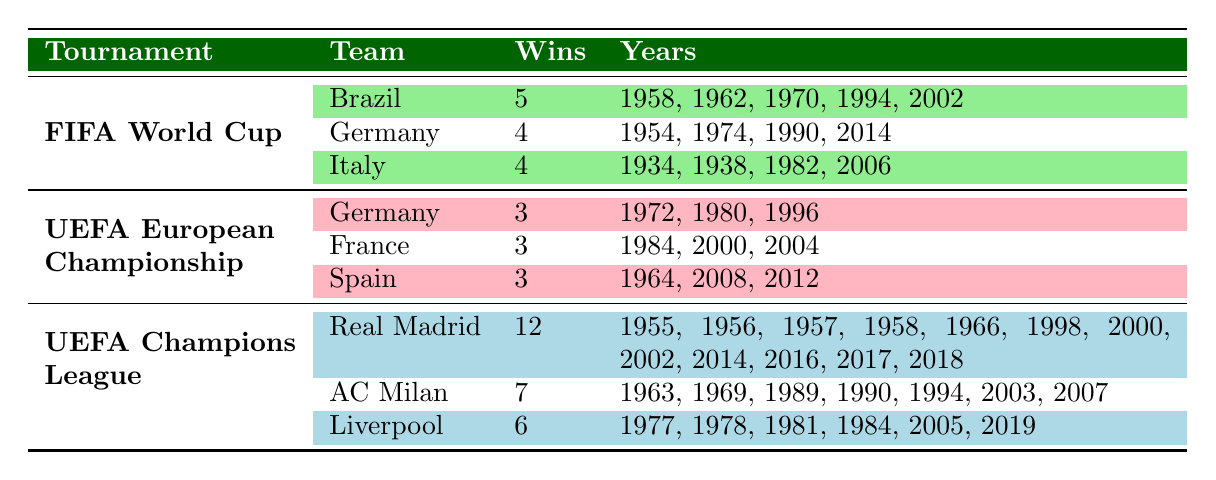What team has the most wins in the UEFA Champions League? Real Madrid has the most wins in the UEFA Champions League with a total of 12 victories, as indicated in the "Wins" column.
Answer: Real Madrid How many titles has Brazil won in the FIFA World Cup? Brazil has won the FIFA World Cup a total of 5 times, which is evident from the "Wins" column under the FIFA World Cup section.
Answer: 5 Did Italy win the UEFA European Championship more times than France? Italy and France have both won the UEFA European Championship 3 times, according to the table. Thus, it is false that Italy has more wins than France.
Answer: No Which team has the same number of UEFA European Championship wins as Spain? Germany and France both have 3 wins each in the UEFA European Championship, matching Spain's 3 wins. This is seen in the "Wins" column.
Answer: Germany, France How many total wins does Liverpool have across all tournaments listed? Liverpool has 6 wins in the UEFA Champions League. There are no wins recorded for Liverpool in the other tournaments. Therefore, the total number of wins for Liverpool is 6.
Answer: 6 Which team has won the FIFA World Cup more frequently, Germany or Italy? Germany has won the FIFA World Cup 4 times, while Italy has won it 4 times as well, meaning both teams have the same number of wins, as shown in the "Wins" column.
Answer: They are equal What is the average number of wins for teams in the UEFA European Championship? The total wins in the UEFA European Championship are 3 (Germany) + 3 (France) + 3 (Spain) = 9. Since there are 3 teams, the average is 9/3 = 3.
Answer: 3 Which tournament has the highest number of total wins among all teams listed? The UEFA Champions League has the highest number of total wins, with Real Madrid at 12, AC Milan at 7, and Liverpool at 6, which sums up to 25 wins compared to the other tournaments.
Answer: UEFA Champions League Has France won more tournaments in total compared to Brazil? Brazil has won a total of 5 FIFA World Cups and does not appear in the UEFA European Championship wins, while France has 3 wins in the UEFA European Championship. Therefore, Brazil has more wins overall than France.
Answer: No 